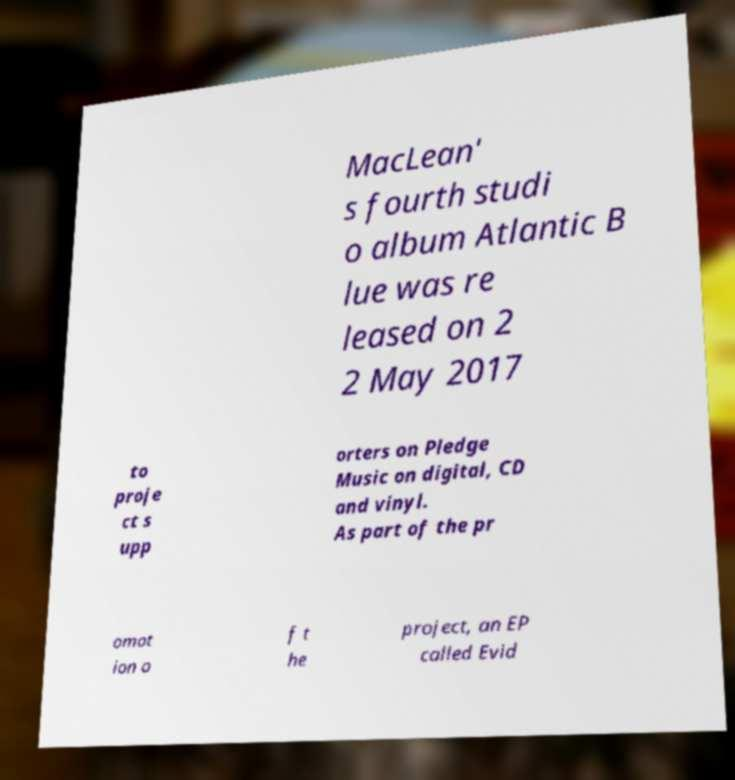Please identify and transcribe the text found in this image. MacLean' s fourth studi o album Atlantic B lue was re leased on 2 2 May 2017 to proje ct s upp orters on Pledge Music on digital, CD and vinyl. As part of the pr omot ion o f t he project, an EP called Evid 